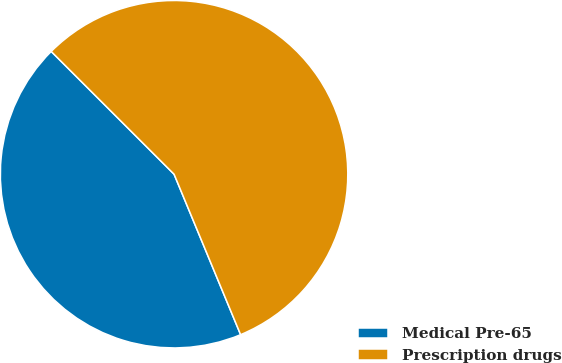Convert chart. <chart><loc_0><loc_0><loc_500><loc_500><pie_chart><fcel>Medical Pre-65<fcel>Prescription drugs<nl><fcel>43.75%<fcel>56.25%<nl></chart> 